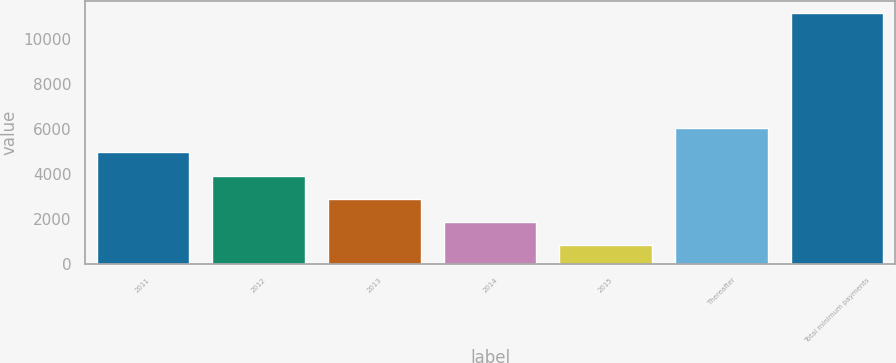Convert chart to OTSL. <chart><loc_0><loc_0><loc_500><loc_500><bar_chart><fcel>2011<fcel>2012<fcel>2013<fcel>2014<fcel>2015<fcel>Thereafter<fcel>Total minimum payments<nl><fcel>4944.72<fcel>3915.29<fcel>2885.86<fcel>1856.43<fcel>827<fcel>6018.1<fcel>11121.3<nl></chart> 